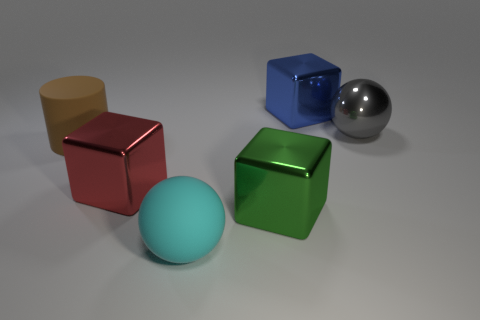Add 3 gray metal things. How many objects exist? 9 Subtract all blue blocks. How many blocks are left? 2 Subtract all spheres. How many objects are left? 4 Subtract 1 balls. How many balls are left? 1 Subtract all large red cubes. Subtract all big purple metallic cylinders. How many objects are left? 5 Add 5 cyan things. How many cyan things are left? 6 Add 1 large green metallic objects. How many large green metallic objects exist? 2 Subtract 0 purple blocks. How many objects are left? 6 Subtract all blue balls. Subtract all purple cylinders. How many balls are left? 2 